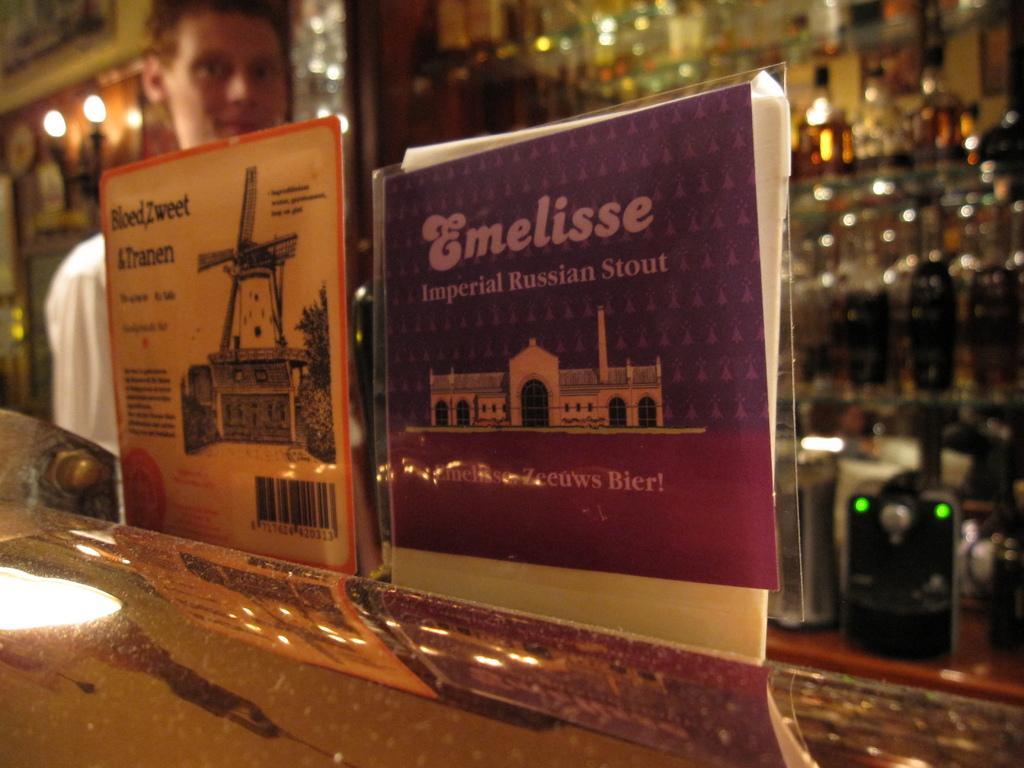How would you summarize this image in a sentence or two? There is a man and this is table. Here we can see posts, lights, rack, bottles, and a device. 